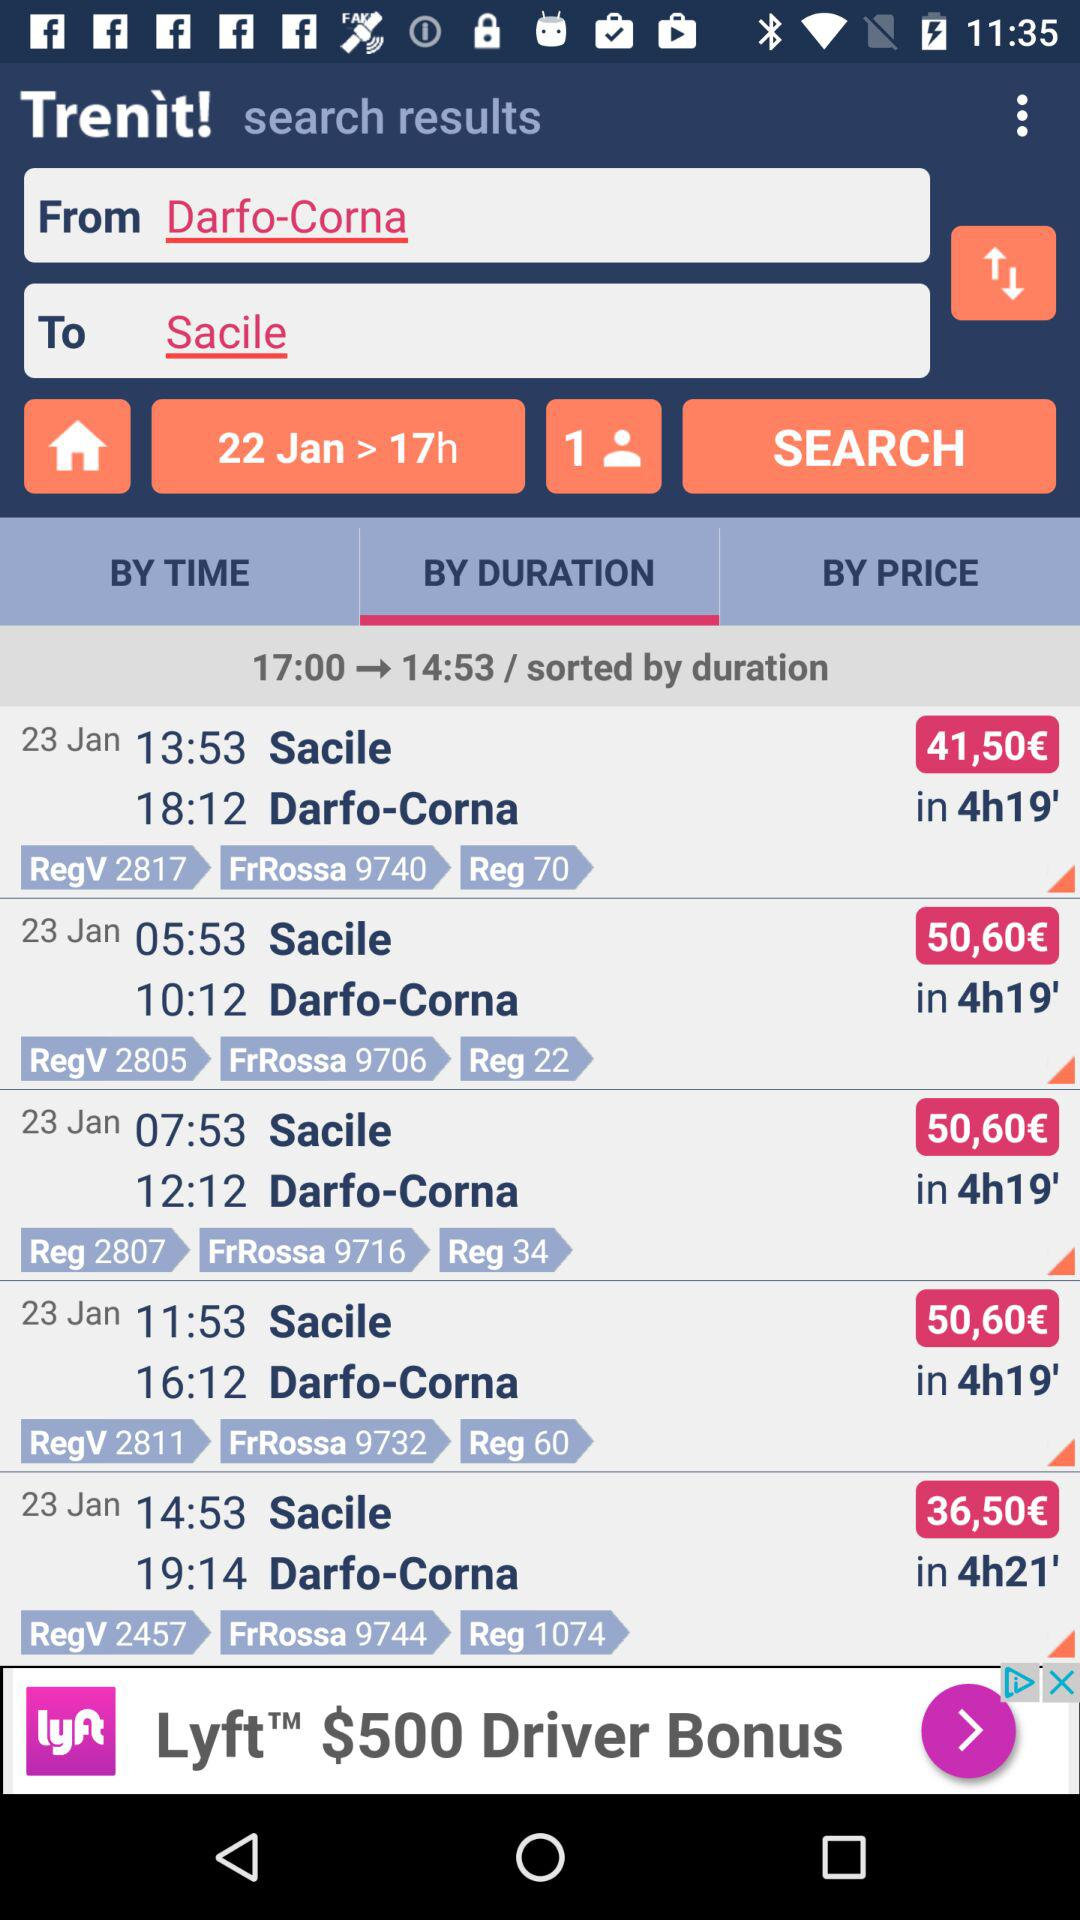What is the fare of the journey from Darfo-Corna to Sacile? The fares are €41.50, €50.60 and €36.50. 